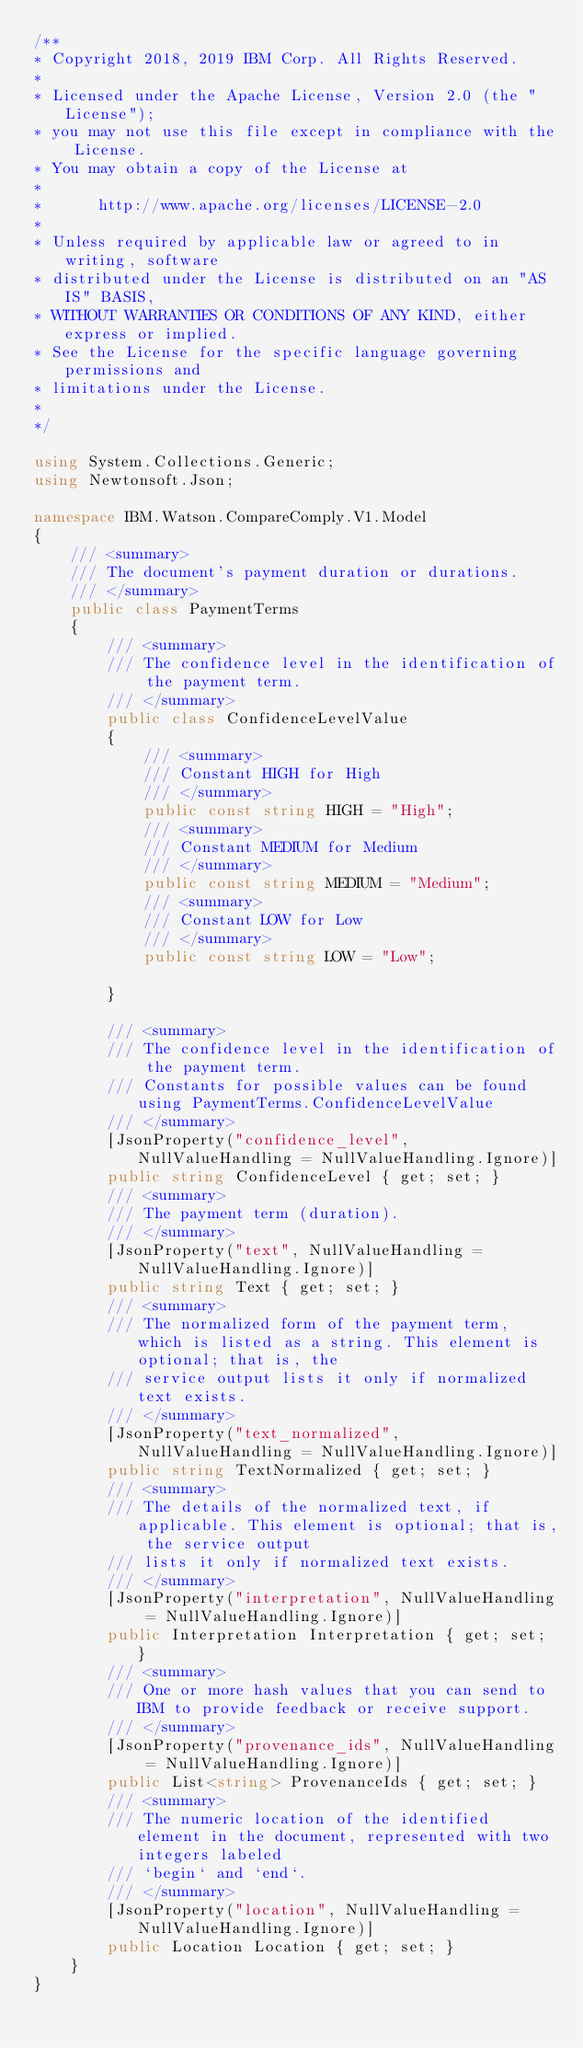<code> <loc_0><loc_0><loc_500><loc_500><_C#_>/**
* Copyright 2018, 2019 IBM Corp. All Rights Reserved.
*
* Licensed under the Apache License, Version 2.0 (the "License");
* you may not use this file except in compliance with the License.
* You may obtain a copy of the License at
*
*      http://www.apache.org/licenses/LICENSE-2.0
*
* Unless required by applicable law or agreed to in writing, software
* distributed under the License is distributed on an "AS IS" BASIS,
* WITHOUT WARRANTIES OR CONDITIONS OF ANY KIND, either express or implied.
* See the License for the specific language governing permissions and
* limitations under the License.
*
*/

using System.Collections.Generic;
using Newtonsoft.Json;

namespace IBM.Watson.CompareComply.V1.Model
{
    /// <summary>
    /// The document's payment duration or durations.
    /// </summary>
    public class PaymentTerms
    {
        /// <summary>
        /// The confidence level in the identification of the payment term.
        /// </summary>
        public class ConfidenceLevelValue
        {
            /// <summary>
            /// Constant HIGH for High
            /// </summary>
            public const string HIGH = "High";
            /// <summary>
            /// Constant MEDIUM for Medium
            /// </summary>
            public const string MEDIUM = "Medium";
            /// <summary>
            /// Constant LOW for Low
            /// </summary>
            public const string LOW = "Low";
            
        }

        /// <summary>
        /// The confidence level in the identification of the payment term.
        /// Constants for possible values can be found using PaymentTerms.ConfidenceLevelValue
        /// </summary>
        [JsonProperty("confidence_level", NullValueHandling = NullValueHandling.Ignore)]
        public string ConfidenceLevel { get; set; }
        /// <summary>
        /// The payment term (duration).
        /// </summary>
        [JsonProperty("text", NullValueHandling = NullValueHandling.Ignore)]
        public string Text { get; set; }
        /// <summary>
        /// The normalized form of the payment term, which is listed as a string. This element is optional; that is, the
        /// service output lists it only if normalized text exists.
        /// </summary>
        [JsonProperty("text_normalized", NullValueHandling = NullValueHandling.Ignore)]
        public string TextNormalized { get; set; }
        /// <summary>
        /// The details of the normalized text, if applicable. This element is optional; that is, the service output
        /// lists it only if normalized text exists.
        /// </summary>
        [JsonProperty("interpretation", NullValueHandling = NullValueHandling.Ignore)]
        public Interpretation Interpretation { get; set; }
        /// <summary>
        /// One or more hash values that you can send to IBM to provide feedback or receive support.
        /// </summary>
        [JsonProperty("provenance_ids", NullValueHandling = NullValueHandling.Ignore)]
        public List<string> ProvenanceIds { get; set; }
        /// <summary>
        /// The numeric location of the identified element in the document, represented with two integers labeled
        /// `begin` and `end`.
        /// </summary>
        [JsonProperty("location", NullValueHandling = NullValueHandling.Ignore)]
        public Location Location { get; set; }
    }
}
</code> 